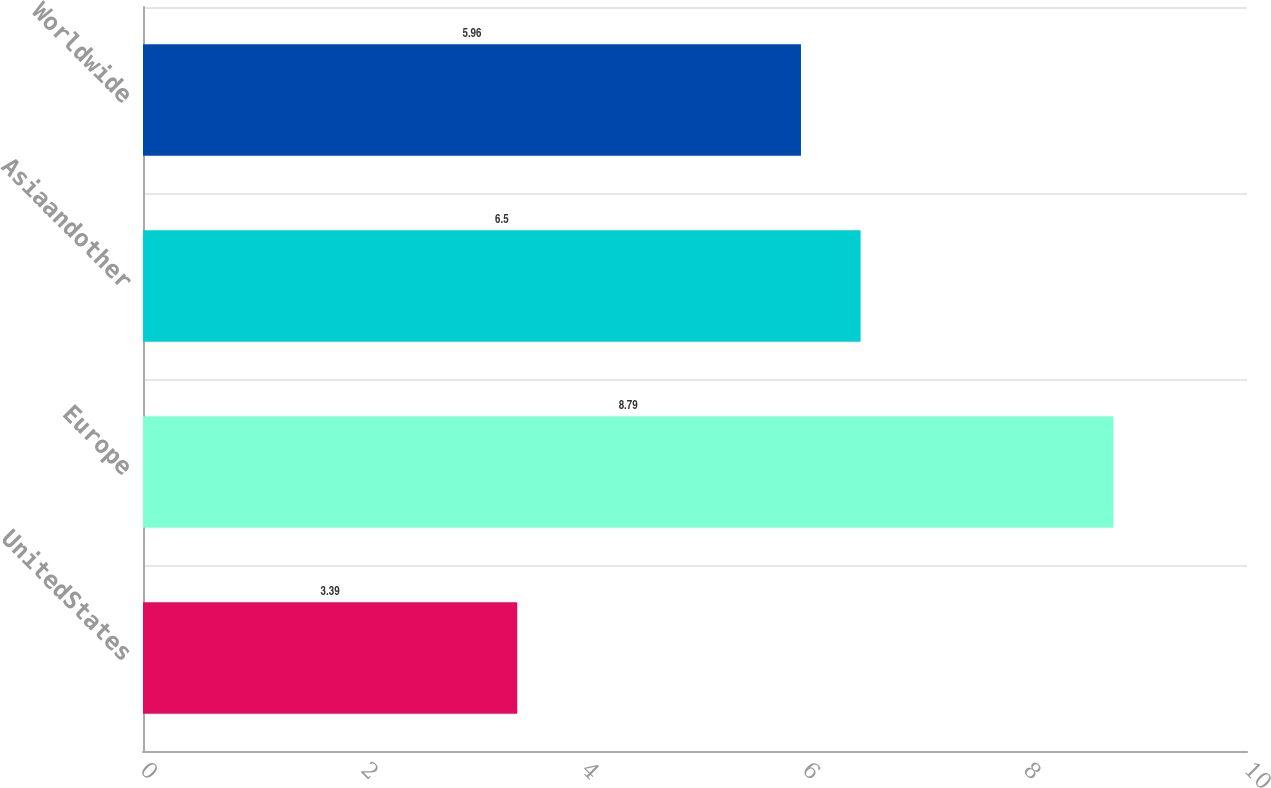Convert chart. <chart><loc_0><loc_0><loc_500><loc_500><bar_chart><fcel>UnitedStates<fcel>Europe<fcel>Asiaandother<fcel>Worldwide<nl><fcel>3.39<fcel>8.79<fcel>6.5<fcel>5.96<nl></chart> 